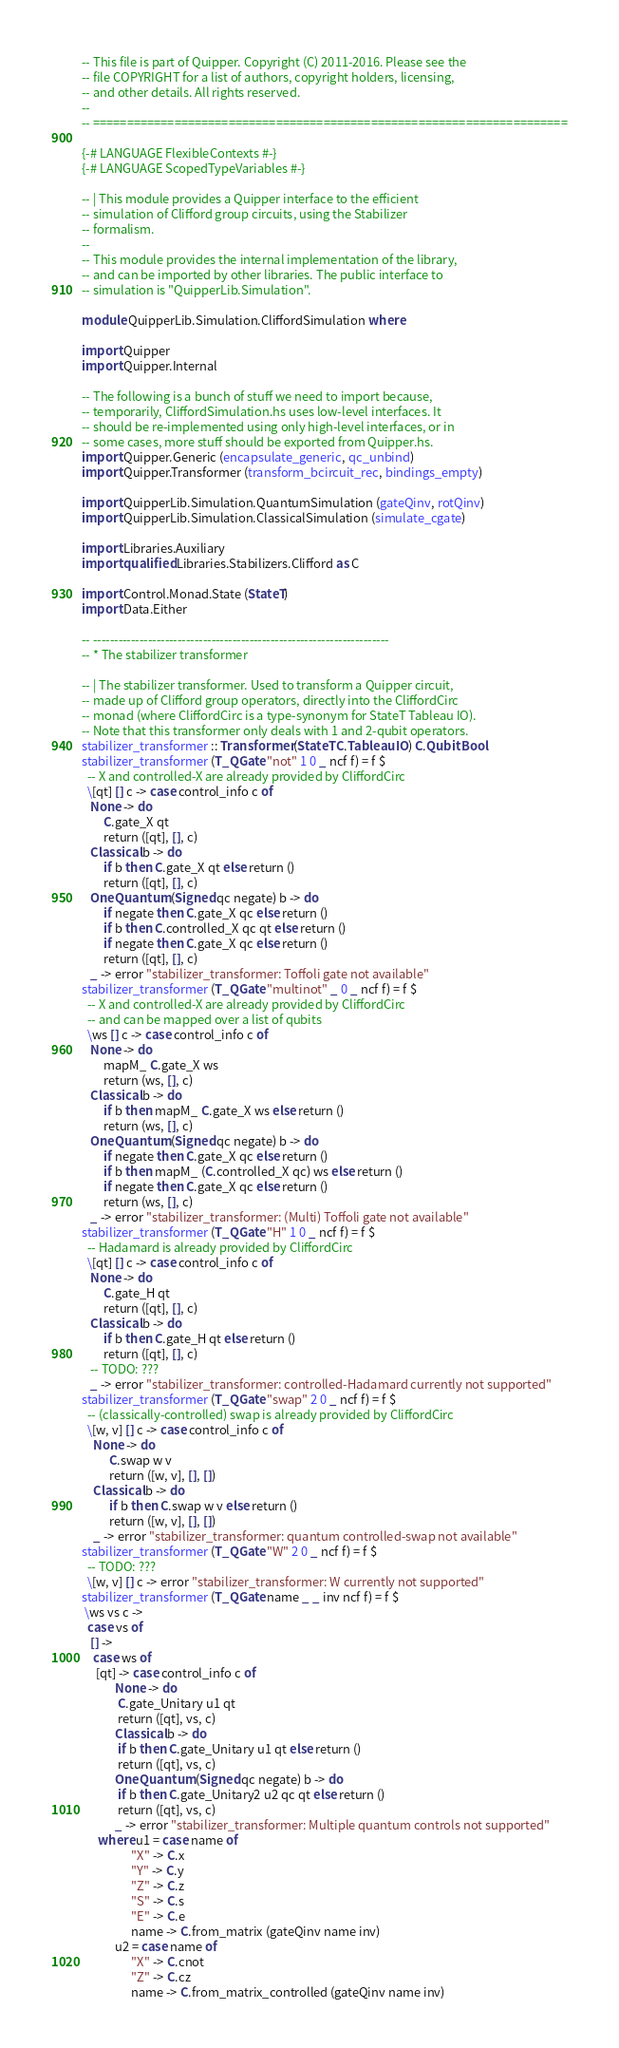<code> <loc_0><loc_0><loc_500><loc_500><_Haskell_>-- This file is part of Quipper. Copyright (C) 2011-2016. Please see the
-- file COPYRIGHT for a list of authors, copyright holders, licensing,
-- and other details. All rights reserved.
-- 
-- ======================================================================

{-# LANGUAGE FlexibleContexts #-}
{-# LANGUAGE ScopedTypeVariables #-}

-- | This module provides a Quipper interface to the efficient
-- simulation of Clifford group circuits, using the Stabilizer
-- formalism.
-- 
-- This module provides the internal implementation of the library,
-- and can be imported by other libraries. The public interface to
-- simulation is "QuipperLib.Simulation".

module QuipperLib.Simulation.CliffordSimulation where

import Quipper
import Quipper.Internal

-- The following is a bunch of stuff we need to import because,
-- temporarily, CliffordSimulation.hs uses low-level interfaces. It
-- should be re-implemented using only high-level interfaces, or in
-- some cases, more stuff should be exported from Quipper.hs.
import Quipper.Generic (encapsulate_generic, qc_unbind)
import Quipper.Transformer (transform_bcircuit_rec, bindings_empty)

import QuipperLib.Simulation.QuantumSimulation (gateQinv, rotQinv)
import QuipperLib.Simulation.ClassicalSimulation (simulate_cgate)

import Libraries.Auxiliary
import qualified Libraries.Stabilizers.Clifford as C

import Control.Monad.State (StateT)
import Data.Either

-- ----------------------------------------------------------------------
-- * The stabilizer transformer

-- | The stabilizer transformer. Used to transform a Quipper circuit,
-- made up of Clifford group operators, directly into the CliffordCirc
-- monad (where CliffordCirc is a type-synonym for StateT Tableau IO).
-- Note that this transformer only deals with 1 and 2-qubit operators.
stabilizer_transformer :: Transformer (StateT C.Tableau IO) C.Qubit Bool
stabilizer_transformer (T_QGate "not" 1 0 _ ncf f) = f $
  -- X and controlled-X are already provided by CliffordCirc
  \[qt] [] c -> case control_info c of
   None -> do
        C.gate_X qt
        return ([qt], [], c)
   Classical b -> do
        if b then C.gate_X qt else return ()
        return ([qt], [], c)
   OneQuantum (Signed qc negate) b -> do
        if negate then C.gate_X qc else return ()
        if b then C.controlled_X qc qt else return ()
        if negate then C.gate_X qc else return ()
        return ([qt], [], c)
   _ -> error "stabilizer_transformer: Toffoli gate not available"
stabilizer_transformer (T_QGate "multinot" _ 0 _ ncf f) = f $
  -- X and controlled-X are already provided by CliffordCirc
  -- and can be mapped over a list of qubits 
  \ws [] c -> case control_info c of
   None -> do
        mapM_ C.gate_X ws
        return (ws, [], c)
   Classical b -> do
        if b then mapM_ C.gate_X ws else return ()
        return (ws, [], c)
   OneQuantum (Signed qc negate) b -> do
        if negate then C.gate_X qc else return ()
        if b then mapM_ (C.controlled_X qc) ws else return ()
        if negate then C.gate_X qc else return ()
        return (ws, [], c)
   _ -> error "stabilizer_transformer: (Multi) Toffoli gate not available"
stabilizer_transformer (T_QGate "H" 1 0 _ ncf f) = f $
  -- Hadamard is already provided by CliffordCirc 
  \[qt] [] c -> case control_info c of
   None -> do
        C.gate_H qt
        return ([qt], [], c)
   Classical b -> do
        if b then C.gate_H qt else return ()
        return ([qt], [], c)
   -- TODO: ???
   _ -> error "stabilizer_transformer: controlled-Hadamard currently not supported"
stabilizer_transformer (T_QGate "swap" 2 0 _ ncf f) = f $
  -- (classically-controlled) swap is already provided by CliffordCirc
  \[w, v] [] c -> case control_info c of
    None -> do
          C.swap w v
          return ([w, v], [], [])
    Classical b -> do
          if b then C.swap w v else return ()
          return ([w, v], [], [])
    _ -> error "stabilizer_transformer: quantum controlled-swap not available"
stabilizer_transformer (T_QGate "W" 2 0 _ ncf f) = f $
  -- TODO: ???
  \[w, v] [] c -> error "stabilizer_transformer: W currently not supported"
stabilizer_transformer (T_QGate name _ _ inv ncf f) = f $
 \ws vs c ->
  case vs of
   [] ->
    case ws of
     [qt] -> case control_info c of
            None -> do
             C.gate_Unitary u1 qt
             return ([qt], vs, c)
            Classical b -> do
             if b then C.gate_Unitary u1 qt else return ()
             return ([qt], vs, c)
            OneQuantum (Signed qc negate) b -> do
             if b then C.gate_Unitary2 u2 qc qt else return ()
             return ([qt], vs, c)
            _ -> error "stabilizer_transformer: Multiple quantum controls not supported"
      where u1 = case name of
                  "X" -> C.x
                  "Y" -> C.y
                  "Z" -> C.z
                  "S" -> C.s
                  "E" -> C.e
                  name -> C.from_matrix (gateQinv name inv)
            u2 = case name of
                  "X" -> C.cnot
                  "Z" -> C.cz
                  name -> C.from_matrix_controlled (gateQinv name inv)</code> 